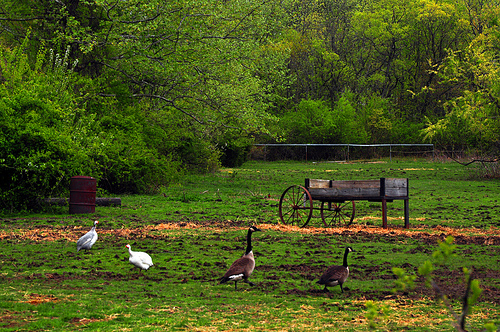<image>
Is there a duck next to the drum? No. The duck is not positioned next to the drum. They are located in different areas of the scene. 